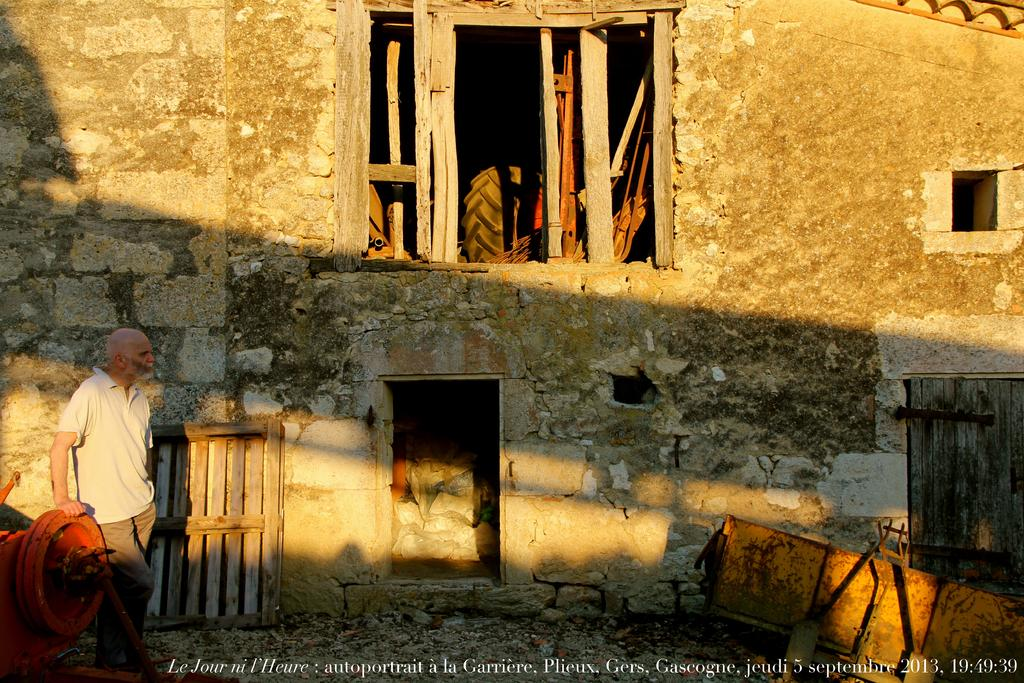<image>
Provide a brief description of the given image. White text on the bottom reads a date of 5 septembre, 2013. 